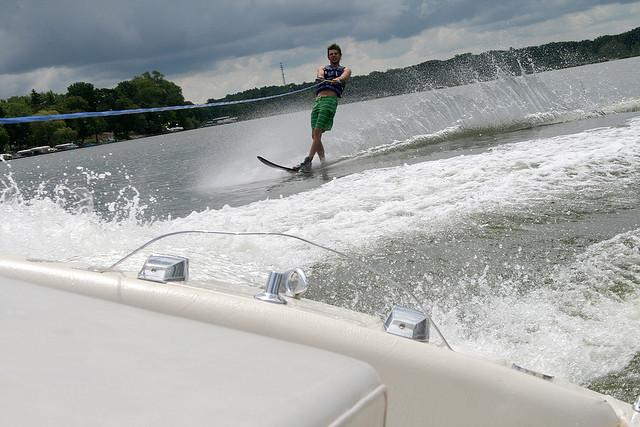What powers the vessel pulling the skier?

Choices:
A) wind
B) coal
C) boat motor
D) sharks boat motor 